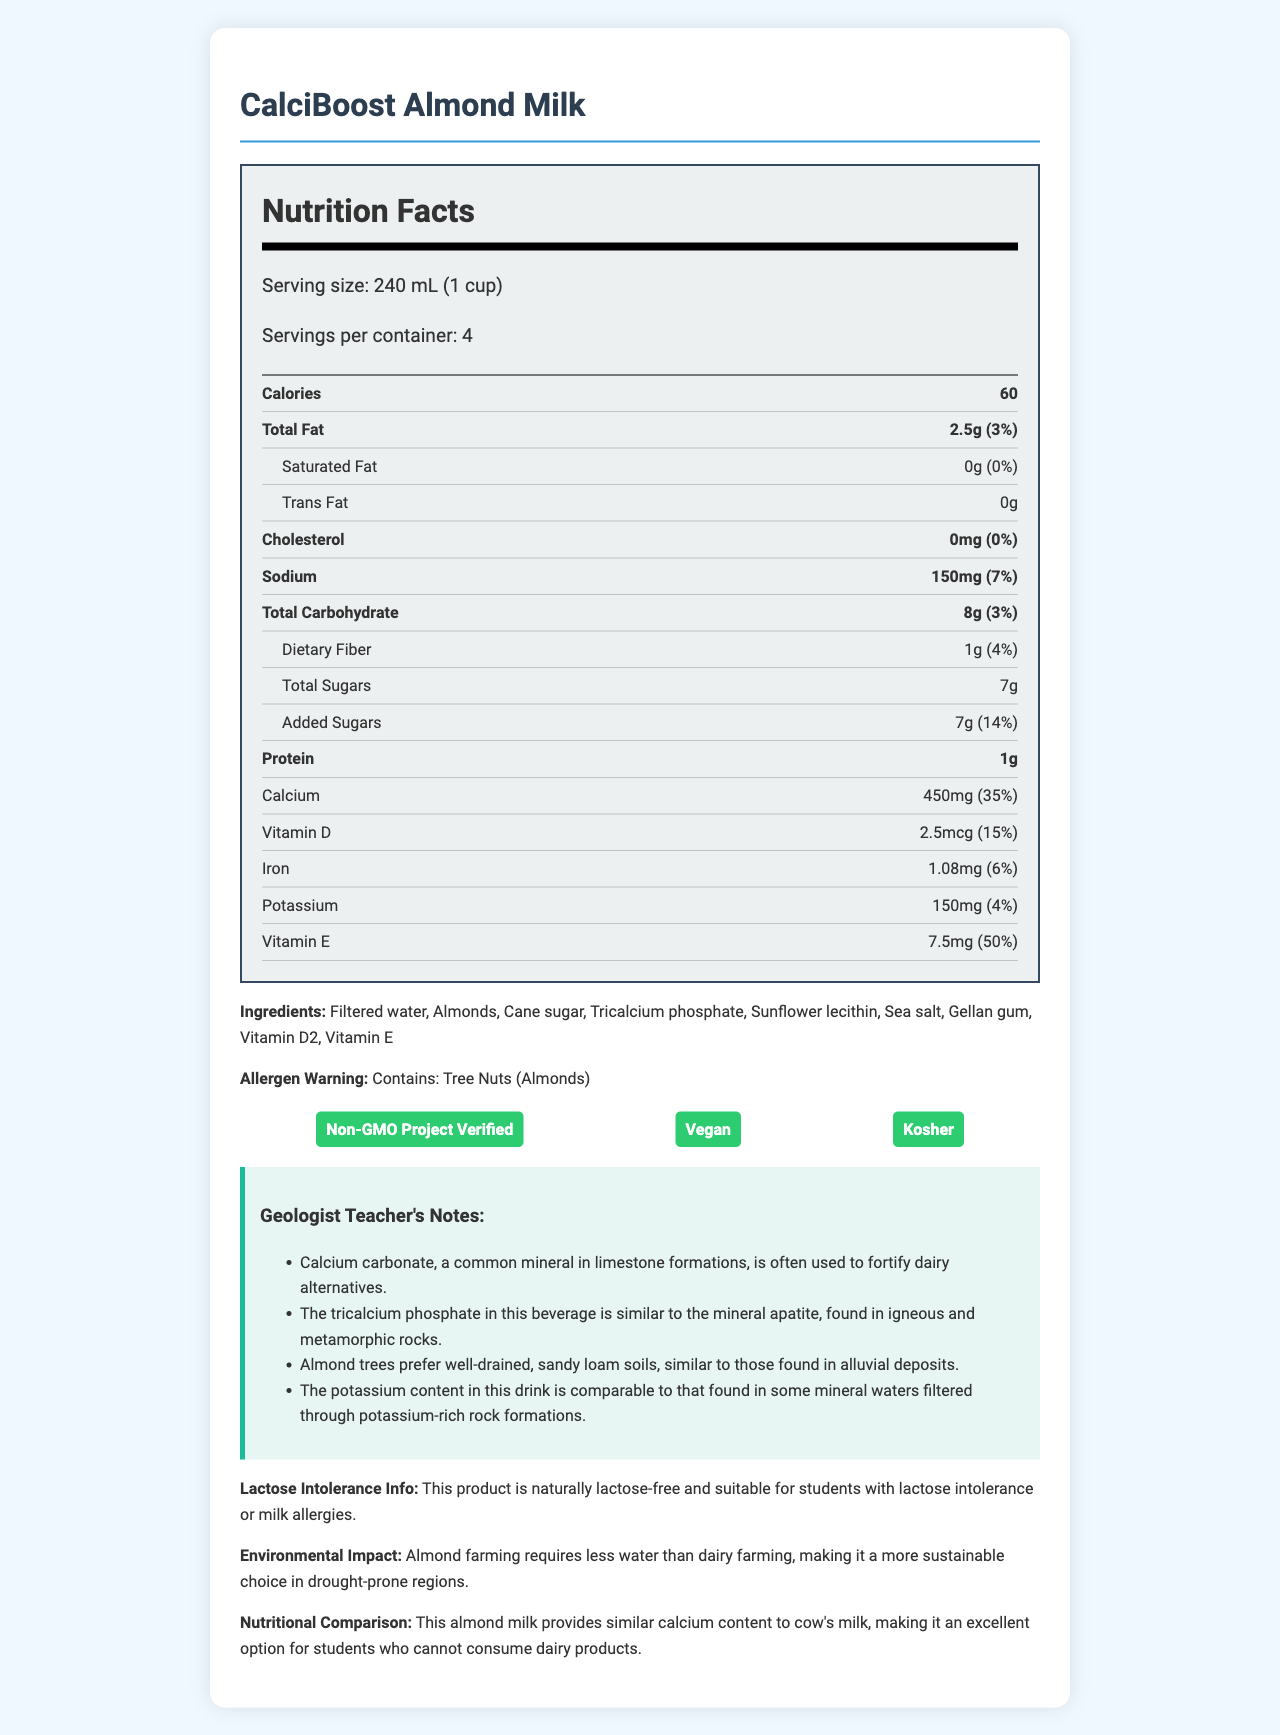what is the serving size of CalciBoost Almond Milk? The serving size is clearly stated in the Nutrition Facts section as "Serving size: 240 mL (1 cup)".
Answer: 240 mL (1 cup) how many servings are in a container of CalciBoost Almond Milk? The document specifies "Servings per container: 4" in the Nutrition Facts section.
Answer: 4 how many calories are there per serving of CalciBoost Almond Milk? The number of calories is mentioned as "Calories: 60" per serving.
Answer: 60 what is the amount of calcium in one serving of CalciBoost Almond Milk? Calcium content per serving is listed as "450mg (35% Daily Value)" in the Nutrition Facts section.
Answer: 450mg what ingredients are used in CalciBoost Almond Milk? The ingredients are listed at the bottom as "Ingredients: Filtered water, Almonds, Cane sugar, Tricalcium phosphate, Sunflower lecithin, Sea salt, Gellan gum, Vitamin D2, Vitamin E".
Answer: Filtered water, Almonds, Cane sugar, Tricalcium phosphate, Sunflower lecithin, Sea salt, Gellan gum, Vitamin D2, Vitamin E which of the following is a certification obtained by CalciBoost Almond Milk? A. USDA Organic B. Non-GMO Project Verified C. Fair Trade Certified D. Gluten-Free The document lists the certifications with "Non-GMO Project Verified" being one of them.
Answer: B how much total fat is in one serving of CalciBoost Almond Milk? A. 1g B. 2.5g C. 0g D. 3g According to the Nutrition Facts, the amount of total fat is "2.5g (3% Daily Value)".
Answer: B Does CalciBoost Almond Milk contain any lactose? The document highlights "This product is naturally lactose-free" indicating it is suitable for lactose-intolerant students.
Answer: No Is CalciBoost Almond Milk vegan? The document lists "Vegan" as one of its certifications, confirming it is a vegan product.
Answer: Yes what is the main purpose of CalciBoost Almond Milk according to the document? The main idea highlighted is that it is a lactose-free, calcium-rich alternative to dairy.
Answer: It provides a calcium-rich dairy alternative beverage suitable for lactose-intolerant students. how many grams of protein are in a serving of CalciBoost Almond Milk? The Nutrition Facts section specifies "Protein: 1g".
Answer: 1g what is the source of vitamin D in CalciBoost Almond Milk? The ingredients list includes "Vitamin D2", which indicates the source of vitamin D.
Answer: Vitamin D2 What is the environmental impact mentioned for almond farming compared to dairy farming? The document states "Almond farming requires less water than dairy farming, making it a more sustainable choice in drought-prone regions."
Answer: Almond farming requires less water than dairy farming. How much added sugar is in one serving of CalciBoost Almond Milk? The Nutrition Facts section lists "Added Sugars: 7g (14% Daily Value)".
Answer: 7g What is the detailed comparison of nutrients between CalciBoost Almond Milk and cow's milk according to the document? The document states that CalciBoost almond milk provides similar calcium content to cow's milk but does not provide a detailed nutrient comparison for all nutrients.
Answer: Cannot be determined 